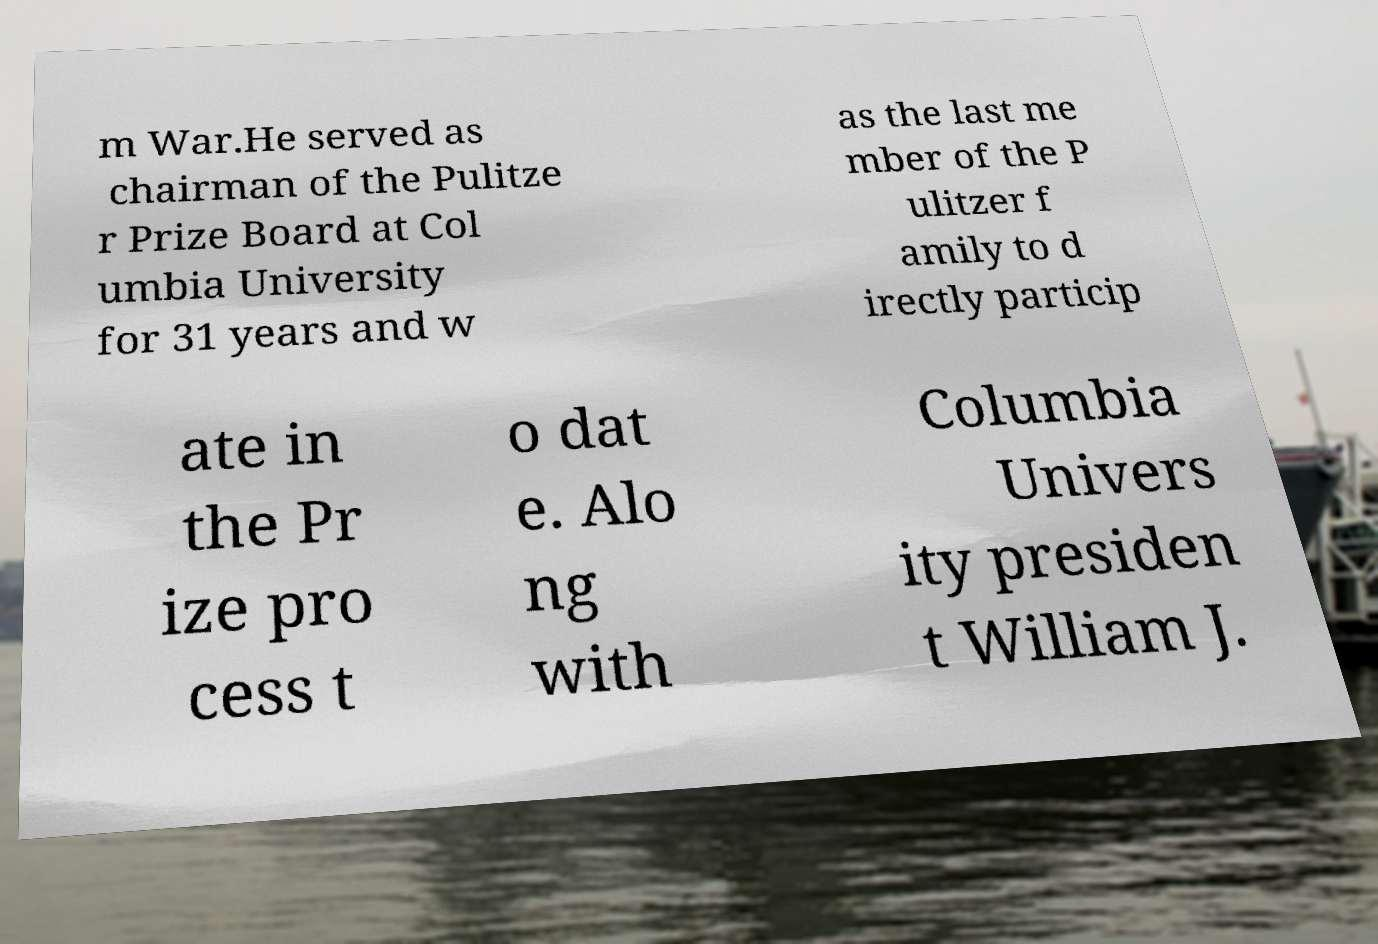There's text embedded in this image that I need extracted. Can you transcribe it verbatim? m War.He served as chairman of the Pulitze r Prize Board at Col umbia University for 31 years and w as the last me mber of the P ulitzer f amily to d irectly particip ate in the Pr ize pro cess t o dat e. Alo ng with Columbia Univers ity presiden t William J. 